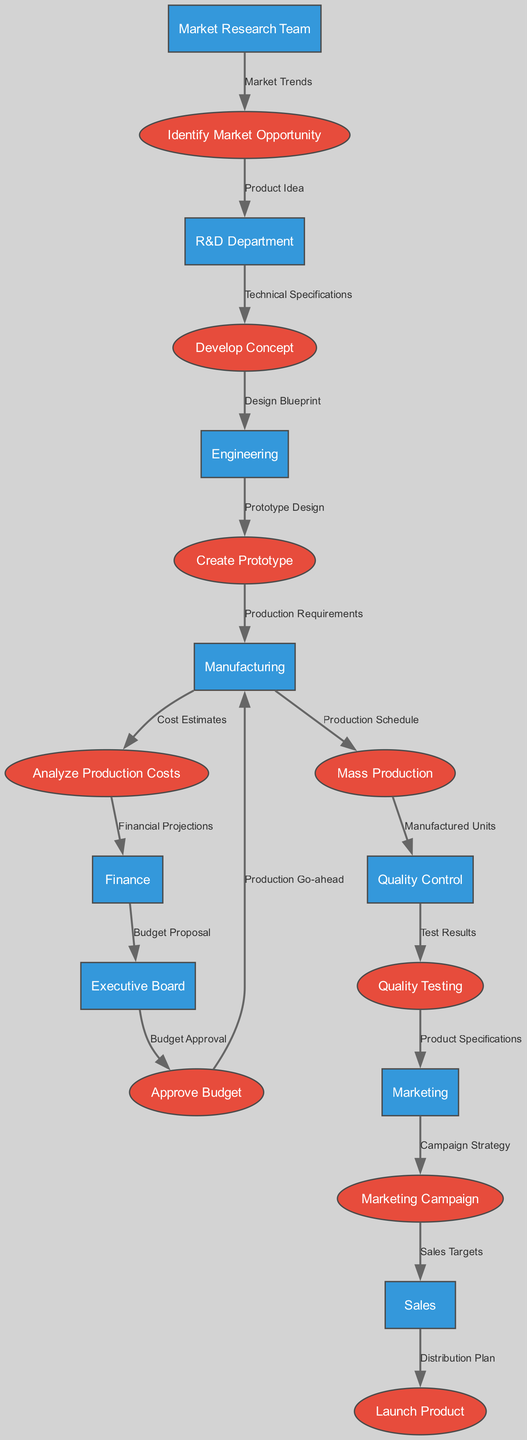What is the first process in the product development lifecycle? The first process is 'Identify Market Opportunity', which is depicted as the starting point in the diagram.
Answer: Identify Market Opportunity How many entities are involved in the diagram? By counting the unique names listed under entities, we find a total of nine entities.
Answer: Nine What is the last step before the product is launched? The last step before the product launch is the 'Sales' process, where the distribution plan is finalized before the launch.
Answer: Sales Which entity receives the 'Budget Proposal'? The 'Budget Proposal' is sent to the 'Executive Board' from the 'Finance' department as part of the budget approval process.
Answer: Executive Board What are the main outputs of the 'Quality Control' process? The main output of the 'Quality Control' process is 'Test Results', which are then passed to the 'Quality Testing' process for further evaluation.
Answer: Test Results Which process does 'Analyze Production Costs' lead to? The process 'Analyze Production Costs' leads to the 'Finance' node, indicating that cost analysis is shared with the finance team for approval processes.
Answer: Finance What is the data passed from 'Engineering' to 'Create Prototype'? The data passed from 'Engineering' to 'Create Prototype' is 'Prototype Design', which is essential for the next steps in the product development lifecycle.
Answer: Prototype Design Which team is responsible for the initial market trends analysis? The 'Market Research Team' is responsible for the initial market trends analysis, which is the foundation for identifying market opportunities.
Answer: Market Research Team What data flow leads into the 'Approve Budget' process? The data flow leading into the 'Approve Budget' process comes from the 'Executive Board', indicating that it is a crucial step for budget finalization.
Answer: Budget Approval 